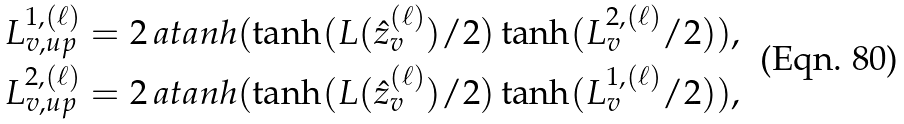Convert formula to latex. <formula><loc_0><loc_0><loc_500><loc_500>L _ { v , u p } ^ { 1 , ( \ell ) } & = 2 \, a t a n h ( \tanh ( L ( \hat { z } _ { v } ^ { ( \ell ) } ) / 2 ) \tanh ( L _ { v } ^ { 2 , ( \ell ) } / 2 ) ) , \\ L _ { v , u p } ^ { 2 , ( \ell ) } & = 2 \, a t a n h ( \tanh ( L ( \hat { z } _ { v } ^ { ( \ell ) } ) / 2 ) \tanh ( L _ { v } ^ { 1 , ( \ell ) } / 2 ) ) ,</formula> 